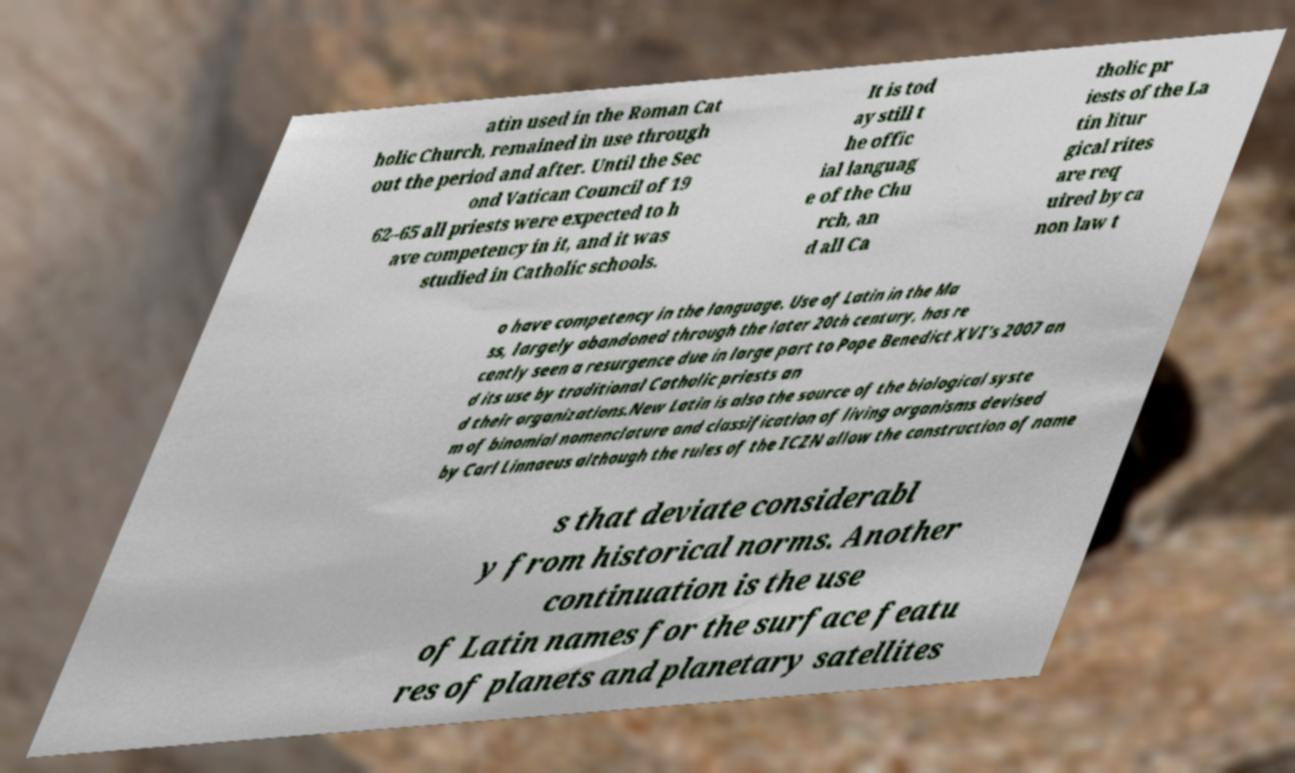I need the written content from this picture converted into text. Can you do that? atin used in the Roman Cat holic Church, remained in use through out the period and after. Until the Sec ond Vatican Council of 19 62–65 all priests were expected to h ave competency in it, and it was studied in Catholic schools. It is tod ay still t he offic ial languag e of the Chu rch, an d all Ca tholic pr iests of the La tin litur gical rites are req uired by ca non law t o have competency in the language. Use of Latin in the Ma ss, largely abandoned through the later 20th century, has re cently seen a resurgence due in large part to Pope Benedict XVI's 2007 an d its use by traditional Catholic priests an d their organizations.New Latin is also the source of the biological syste m of binomial nomenclature and classification of living organisms devised by Carl Linnaeus although the rules of the ICZN allow the construction of name s that deviate considerabl y from historical norms. Another continuation is the use of Latin names for the surface featu res of planets and planetary satellites 